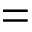<formula> <loc_0><loc_0><loc_500><loc_500>=</formula> 